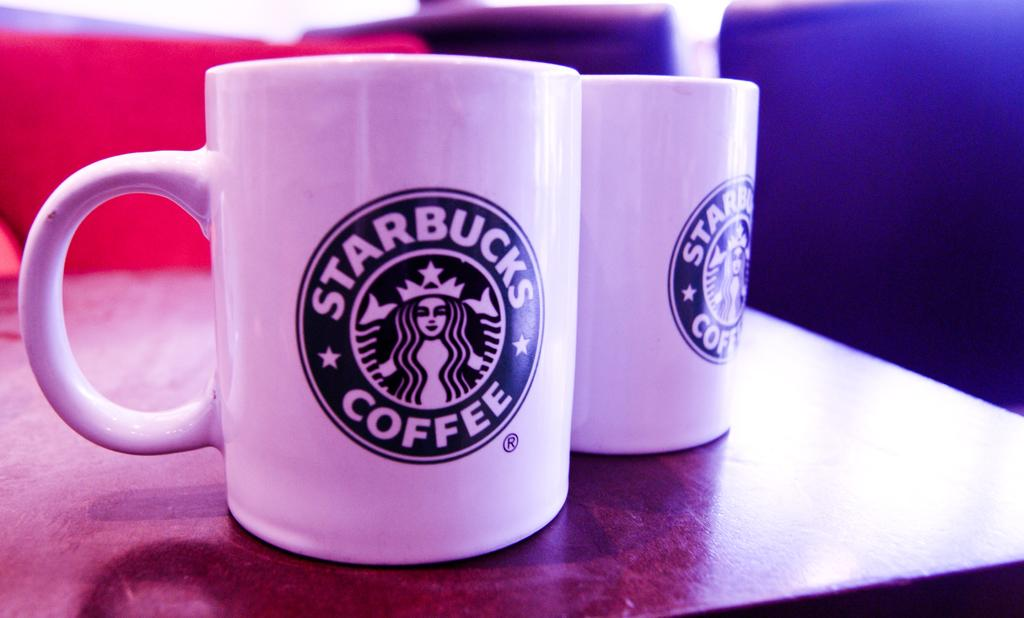<image>
Summarize the visual content of the image. Two coffee mugs with the star bucks coffee logo on them. 